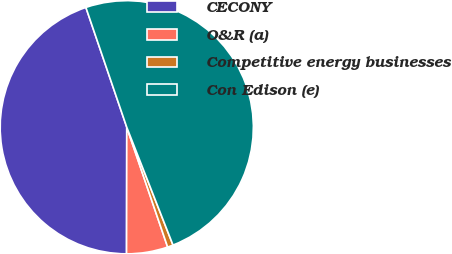<chart> <loc_0><loc_0><loc_500><loc_500><pie_chart><fcel>CECONY<fcel>O&R (a)<fcel>Competitive energy businesses<fcel>Con Edison (e)<nl><fcel>44.74%<fcel>5.26%<fcel>0.72%<fcel>49.28%<nl></chart> 